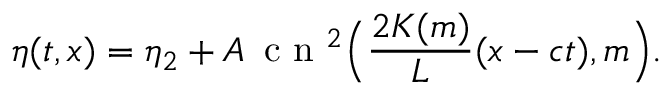<formula> <loc_0><loc_0><loc_500><loc_500>\eta ( t , x ) = \eta _ { 2 } + A \, c n ^ { 2 } \left ( \frac { 2 K ( m ) } { L } ( x - c t ) , m \right ) .</formula> 